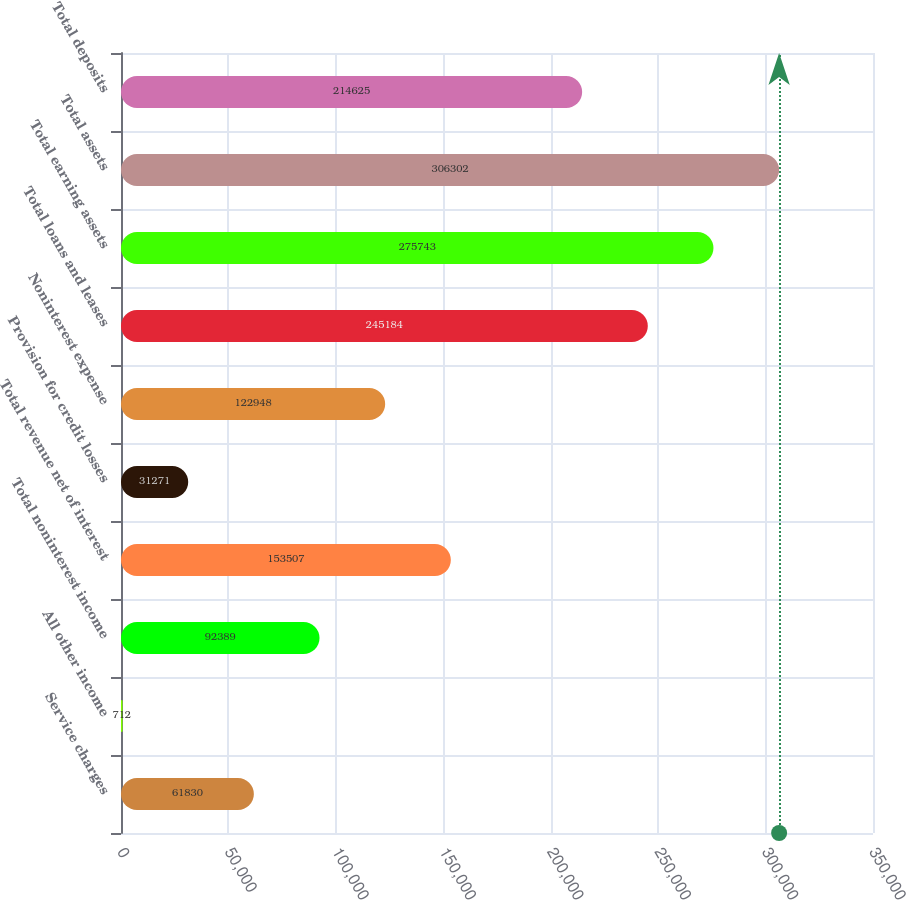Convert chart. <chart><loc_0><loc_0><loc_500><loc_500><bar_chart><fcel>Service charges<fcel>All other income<fcel>Total noninterest income<fcel>Total revenue net of interest<fcel>Provision for credit losses<fcel>Noninterest expense<fcel>Total loans and leases<fcel>Total earning assets<fcel>Total assets<fcel>Total deposits<nl><fcel>61830<fcel>712<fcel>92389<fcel>153507<fcel>31271<fcel>122948<fcel>245184<fcel>275743<fcel>306302<fcel>214625<nl></chart> 